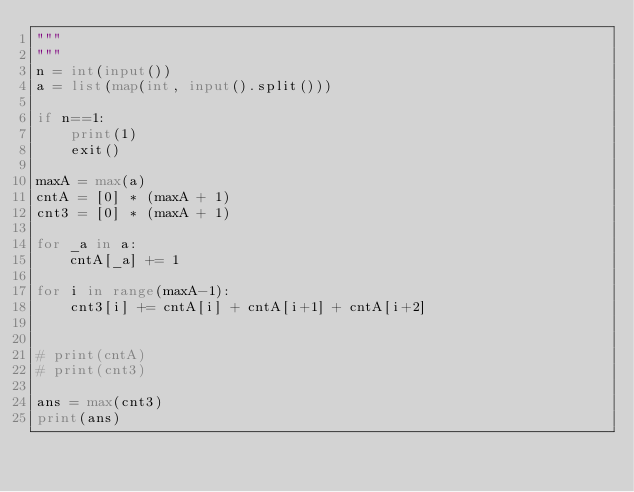Convert code to text. <code><loc_0><loc_0><loc_500><loc_500><_Python_>"""
""" 
n = int(input())
a = list(map(int, input().split()))

if n==1:
    print(1)
    exit()

maxA = max(a)
cntA = [0] * (maxA + 1)
cnt3 = [0] * (maxA + 1)

for _a in a:
    cntA[_a] += 1

for i in range(maxA-1):
    cnt3[i] += cntA[i] + cntA[i+1] + cntA[i+2]


# print(cntA)
# print(cnt3)

ans = max(cnt3)
print(ans)
</code> 